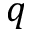<formula> <loc_0><loc_0><loc_500><loc_500>q</formula> 